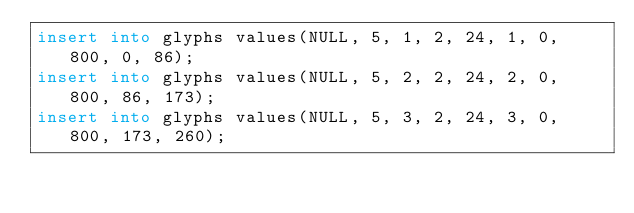<code> <loc_0><loc_0><loc_500><loc_500><_SQL_>insert into glyphs values(NULL, 5, 1, 2, 24, 1, 0, 800, 0, 86);
insert into glyphs values(NULL, 5, 2, 2, 24, 2, 0, 800, 86, 173);
insert into glyphs values(NULL, 5, 3, 2, 24, 3, 0, 800, 173, 260);</code> 